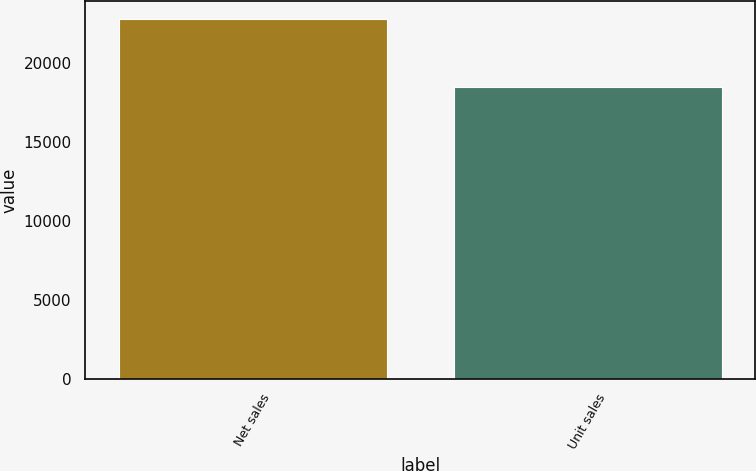<chart> <loc_0><loc_0><loc_500><loc_500><bar_chart><fcel>Net sales<fcel>Unit sales<nl><fcel>22831<fcel>18484<nl></chart> 